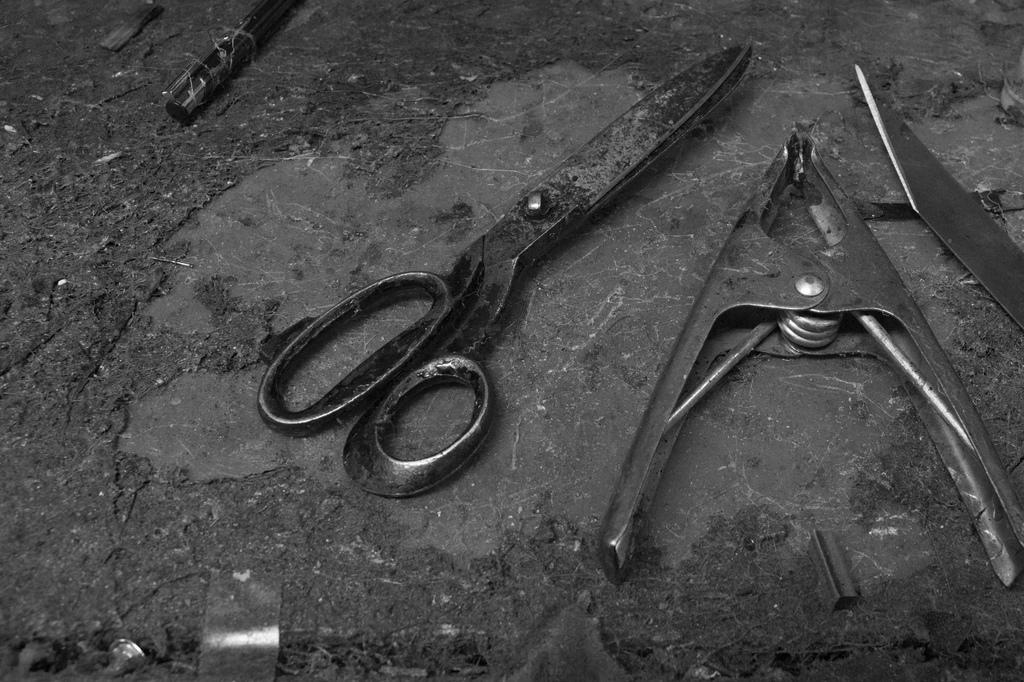What is the primary object in the image? There is a holder in the image. What tools are present in the image? There is a knife and a pen in the image. Can you describe the objects at the bottom of the image? There are nails, steel chips, and other materials at the bottom of the image. How many stamps are visible on the holder in the image? There are no stamps present in the image; the holder contains a knife and a pen. Can you see any rabbits interacting with the objects in the image? There are no rabbits present in the image. 